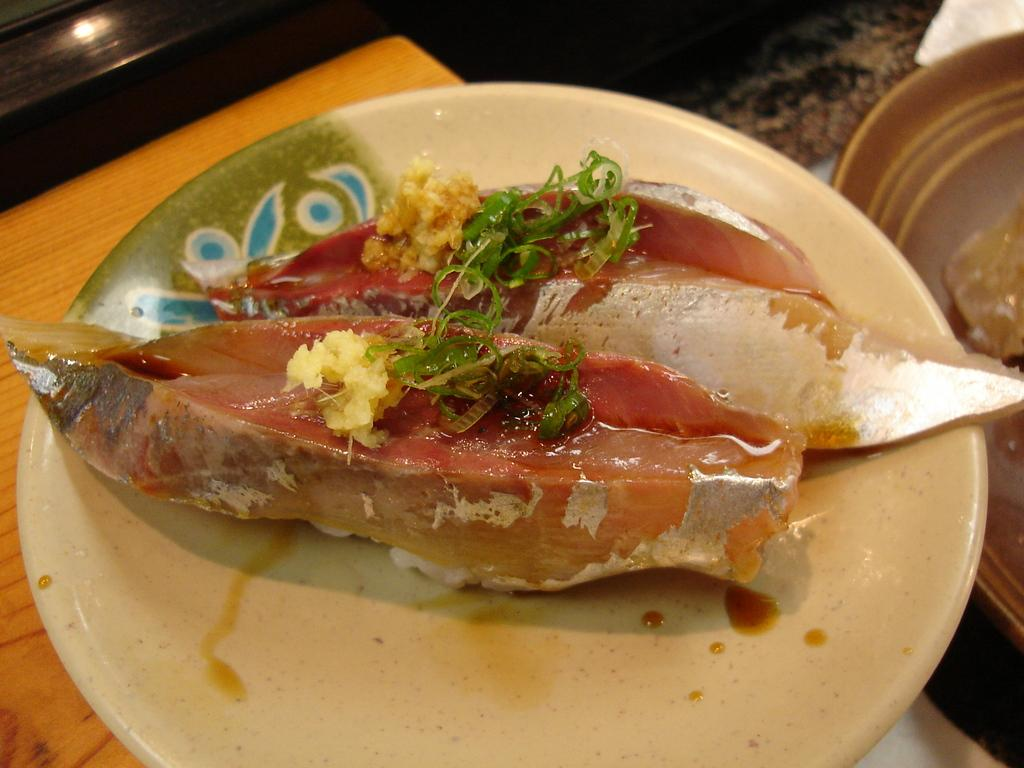What type of food is depicted in the image? There are two fish pieces in the image. Where are the fish pieces located? The fish pieces are on a plate. What is the surface on which the plate is placed? The plate is placed on a wooden table top. What type of scarf is draped over the fish pieces in the image? There is no scarf present in the image; it features two fish pieces on a plate. How many cakes are visible in the image? There are no cakes present in the image; it features two fish pieces on a plate. 